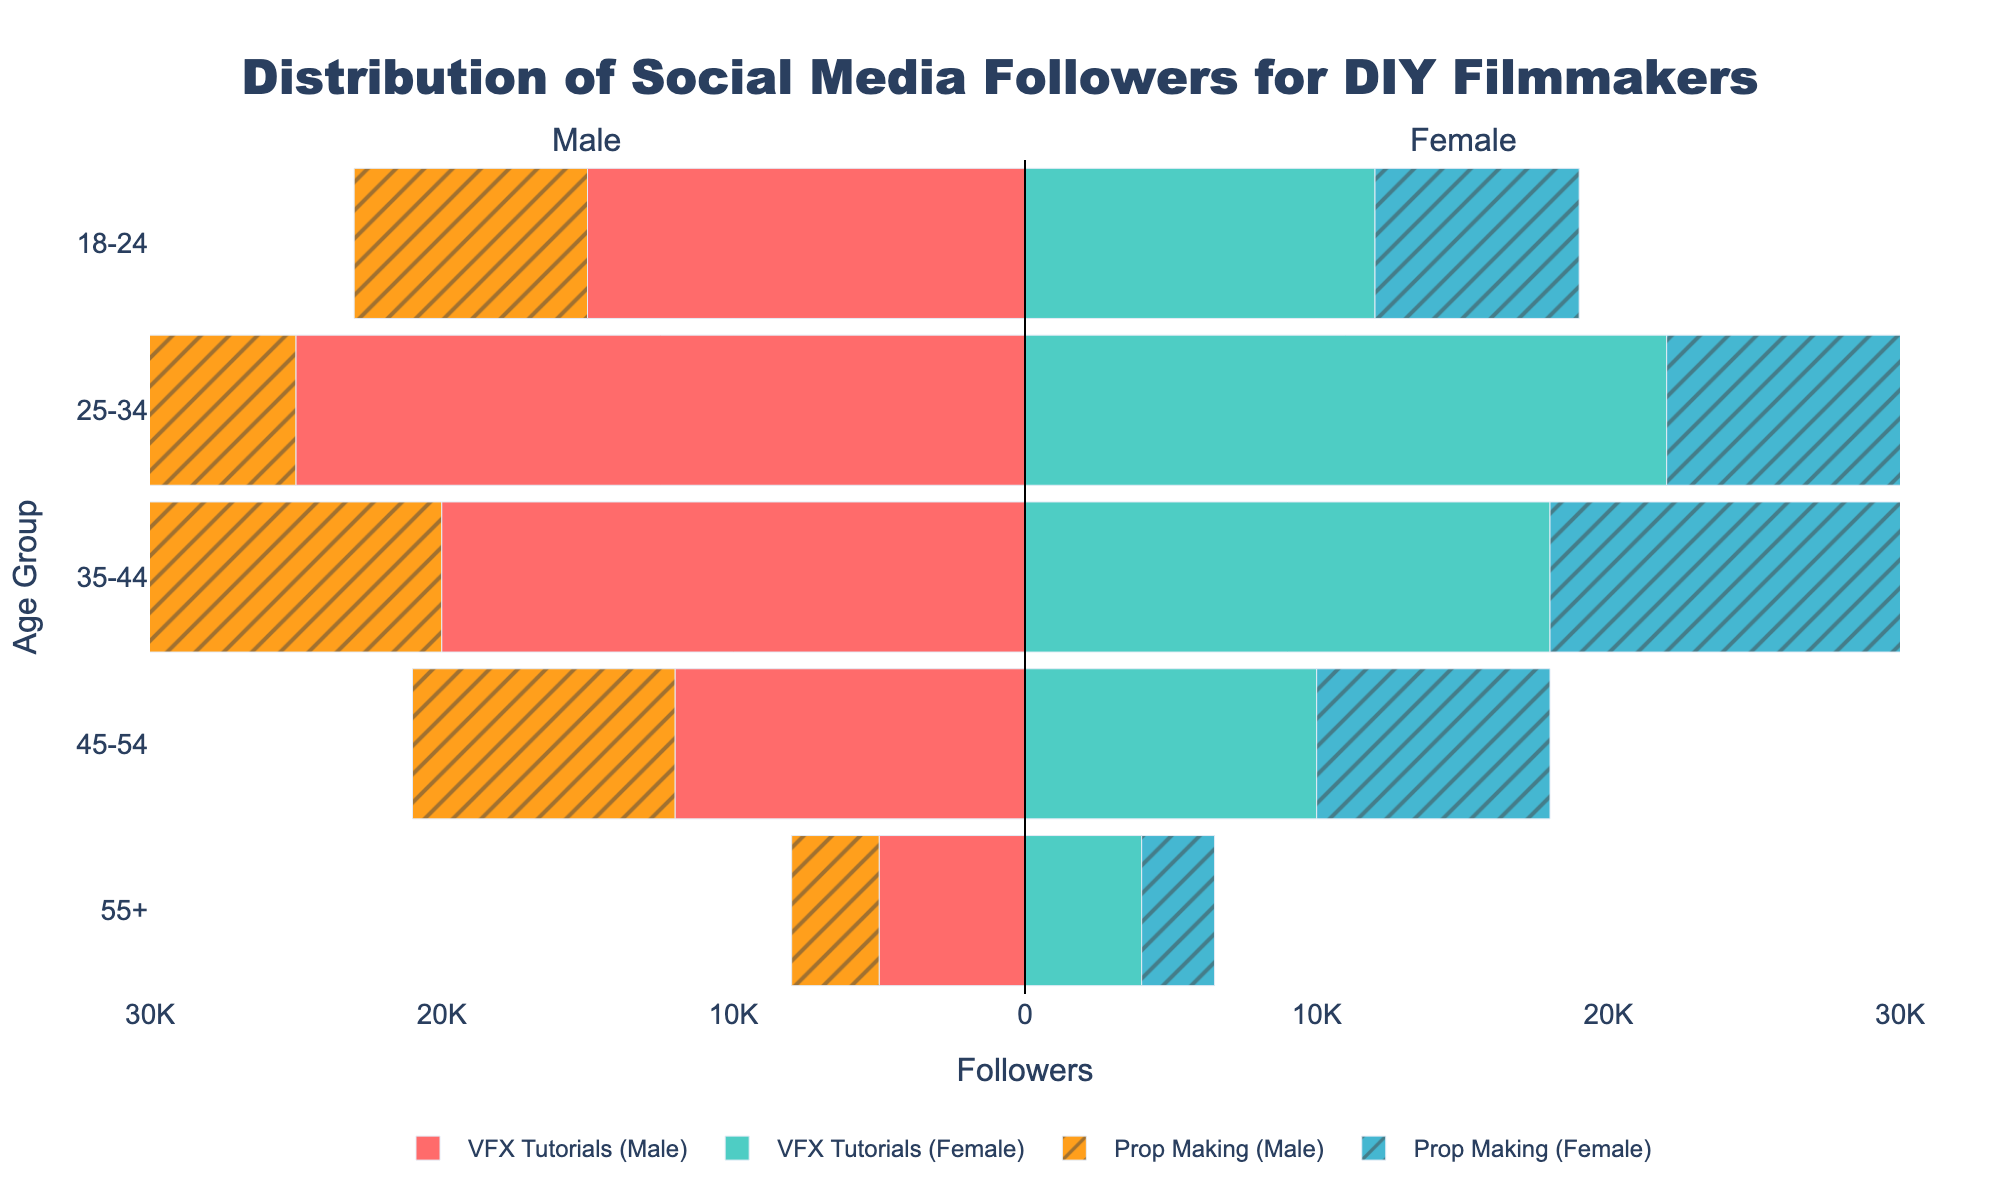What's the title of the plot? The title is located at the top of the figure, centered and in a larger font size than the rest. It reads "Distribution of Social Media Followers for DIY Filmmakers".
Answer: Distribution of Social Media Followers for DIY Filmmakers What is the age group with the highest number of female followers for VFX Tutorials? Look for the bar labeled "VFX Tutorials (Female)" with the largest value on the positive x-axis. The age group associated with this bar is "25-34".
Answer: 25-34 Which content type has more male followers in the 45-54 age group? Compare the lengths of the bars for "VFX Tutorials (Male)" and "Prop Making (Male)" in the 45-54 age group. The longer bar indicates the content type with more followers. "VFX Tutorials (Male)" has a longer bar than "Prop Making (Male)".
Answer: VFX Tutorials How many followers are there in total for males aged 18-24 in both content types? Sum the values of the bars labeled "VFX Tutorials (Male)" and "Prop Making (Male)" in the 18-24 age group. The values are 15,000 and 8,000, respectively. So, 15,000 + 8,000 = 23,000.
Answer: 23,000 In which age group do Prop Making and VFX Tutorials have the most similar number of female followers? Look for age groups where the lengths of the "Prop Making (Female)" and "VFX Tutorials (Female)" bars are closest in size. For the 45-54 age group, the number of female followers is 8,000 for Prop Making and 10,000 for VFX Tutorials. The difference of 2,000 is smaller compared to other age groups.
Answer: 45-54 At what age group is the disparity between male and female followers largest for VFX Tutorials? Examine the bars for "VFX Tutorials (Male)" and "VFX Tutorials (Female)" across all age groups. The greatest difference is found by subtracting the female follower count from the male follower count. At age group 25-34, it's 25,000 (male) - 22,000 (female) = 3,000, showing the largest disparity.
Answer: 25-34 Which gender has more followers overall for the Prop Making content type? Compare the sum of the lengths of bars labeled "Prop Making (Female)" to the negative sums of "Prop Making (Male)" bars across all age groups. For Prop Making (Female), the total is 7,000 + 16,000 + 14,000 + 8,000 + 2,500 = 47,500. For Prop Making (Male), the total is 8,000 + 18,000 + 15,000 + 9,000 + 3,000 = 53,000, so males have more followers in total.
Answer: Male What is the followership difference between male and female in the 55+ age group for Prop Making? Subtract the number of female followers from the number of male followers in the 55+ age group. The data is 3,000 (male) - 2,500 (female) = 500.
Answer: 500 Are there any age groups where the number of male followers in VFX Tutorials is less than 10,000? Check all age groups under "VFX Tutorials (Male)" where the bar length is less than 10,000 on the negative x-axis. Only the 55+ age group has fewer than 10,000 male followers with 5,000.
Answer: Yes, 55+ 